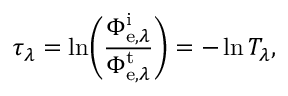<formula> <loc_0><loc_0><loc_500><loc_500>\tau _ { \lambda } = \ln \, \left ( { \frac { \Phi _ { e , \lambda } ^ { i } } { \Phi _ { e , \lambda } ^ { t } } } \right ) = - \ln T _ { \lambda } ,</formula> 